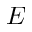Convert formula to latex. <formula><loc_0><loc_0><loc_500><loc_500>E</formula> 